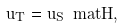Convert formula to latex. <formula><loc_0><loc_0><loc_500><loc_500>\vec { u } _ { T } = \vec { u } _ { S } \ m a t { H } ,</formula> 